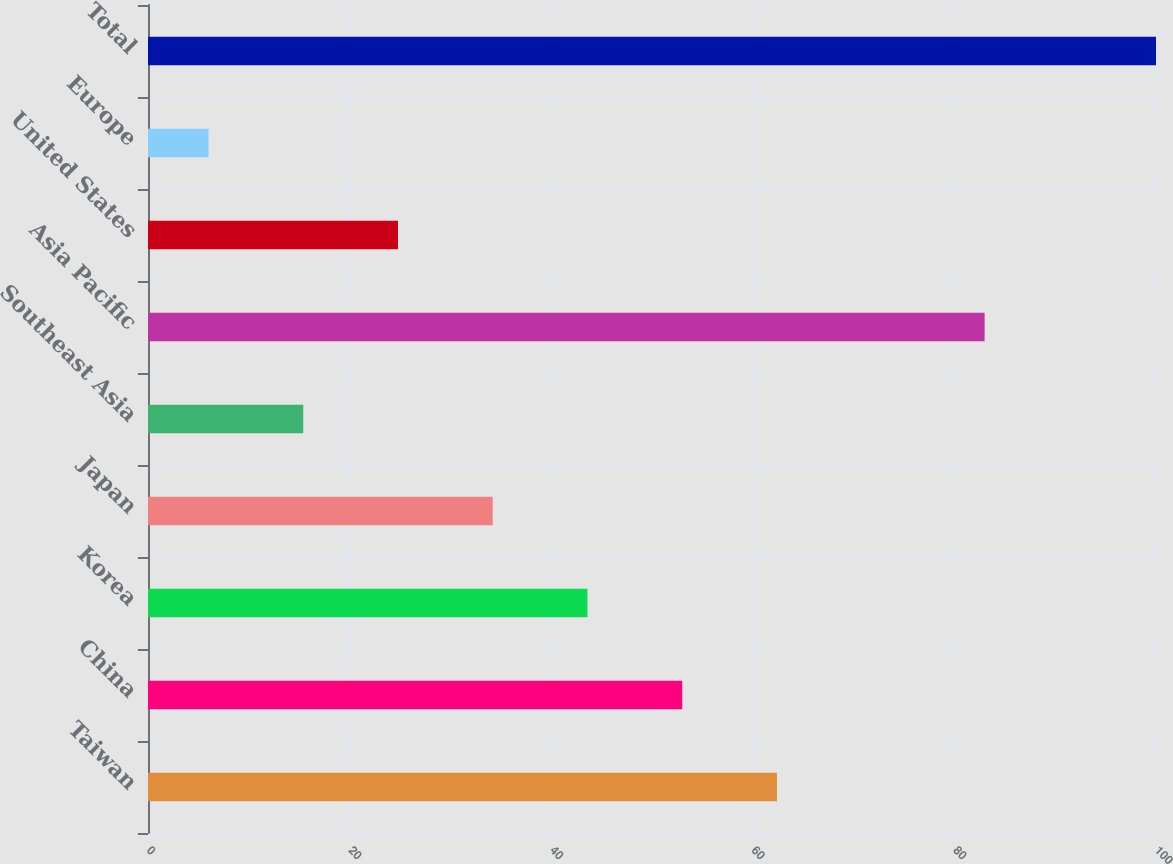<chart> <loc_0><loc_0><loc_500><loc_500><bar_chart><fcel>Taiwan<fcel>China<fcel>Korea<fcel>Japan<fcel>Southeast Asia<fcel>Asia Pacific<fcel>United States<fcel>Europe<fcel>Total<nl><fcel>62.4<fcel>53<fcel>43.6<fcel>34.2<fcel>15.4<fcel>83<fcel>24.8<fcel>6<fcel>100<nl></chart> 